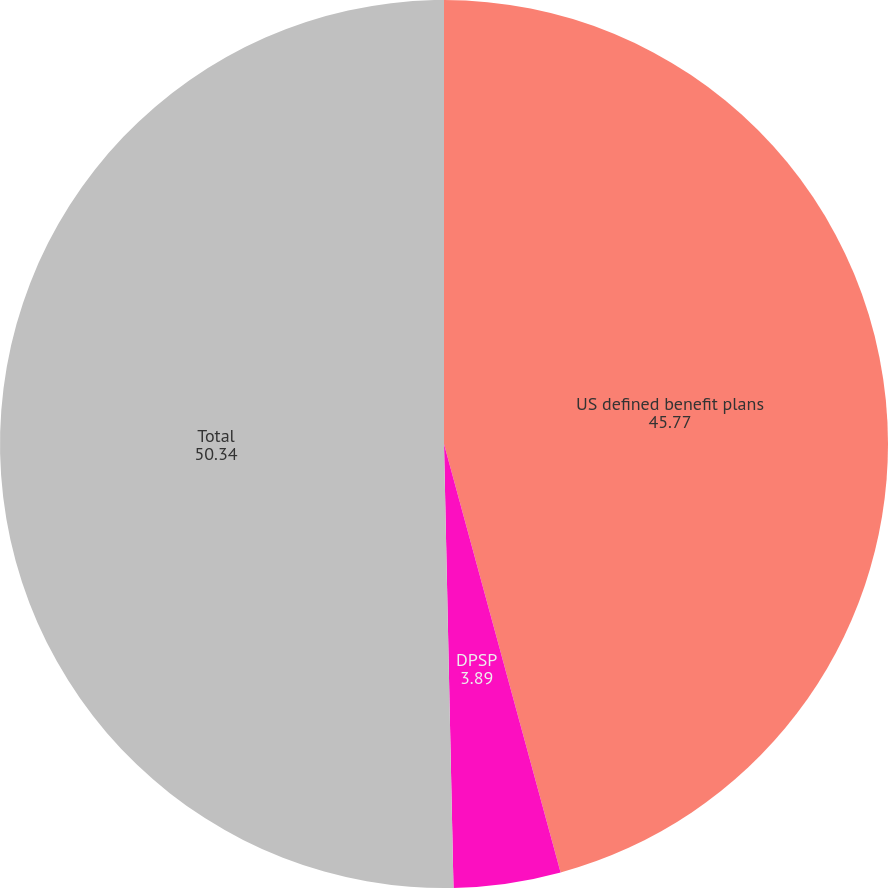Convert chart. <chart><loc_0><loc_0><loc_500><loc_500><pie_chart><fcel>US defined benefit plans<fcel>DPSP<fcel>Total<nl><fcel>45.77%<fcel>3.89%<fcel>50.34%<nl></chart> 